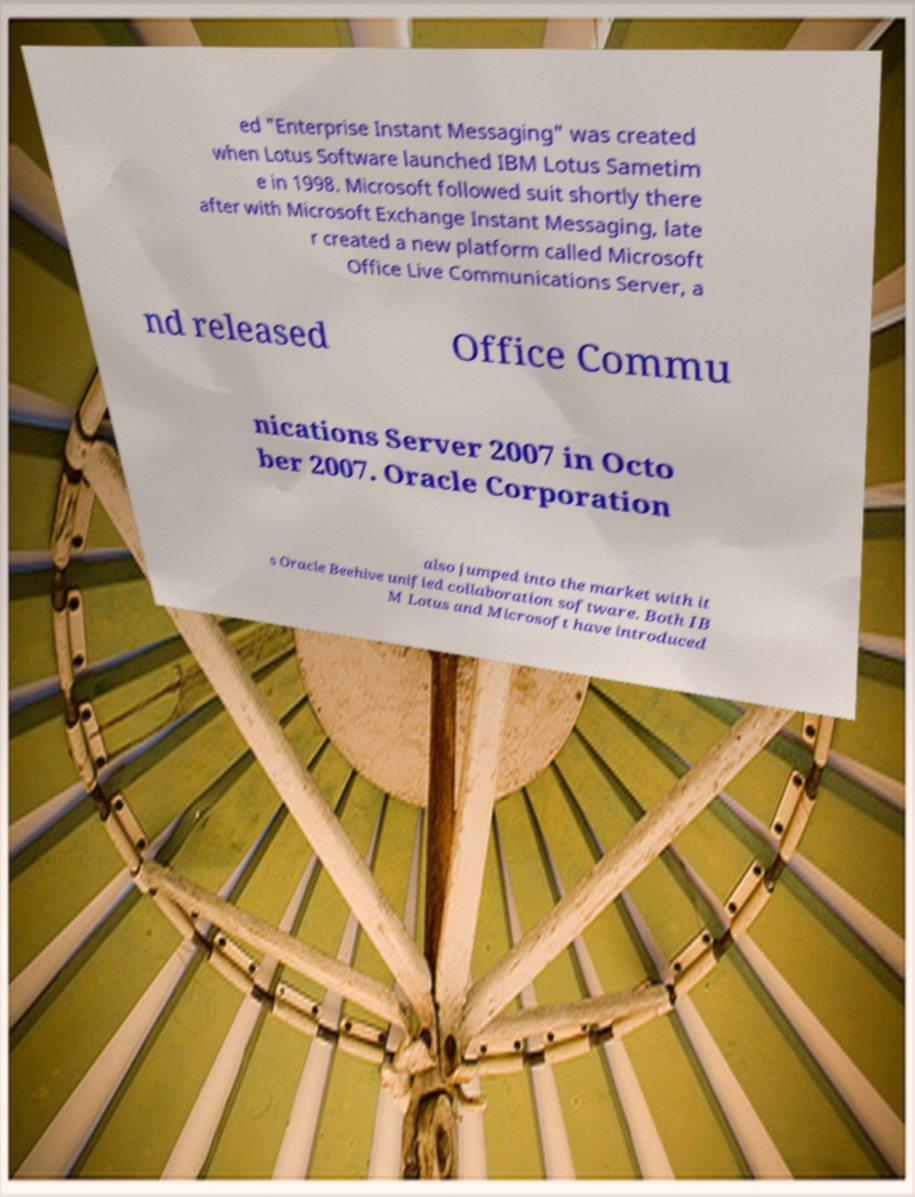Please identify and transcribe the text found in this image. ed "Enterprise Instant Messaging" was created when Lotus Software launched IBM Lotus Sametim e in 1998. Microsoft followed suit shortly there after with Microsoft Exchange Instant Messaging, late r created a new platform called Microsoft Office Live Communications Server, a nd released Office Commu nications Server 2007 in Octo ber 2007. Oracle Corporation also jumped into the market with it s Oracle Beehive unified collaboration software. Both IB M Lotus and Microsoft have introduced 